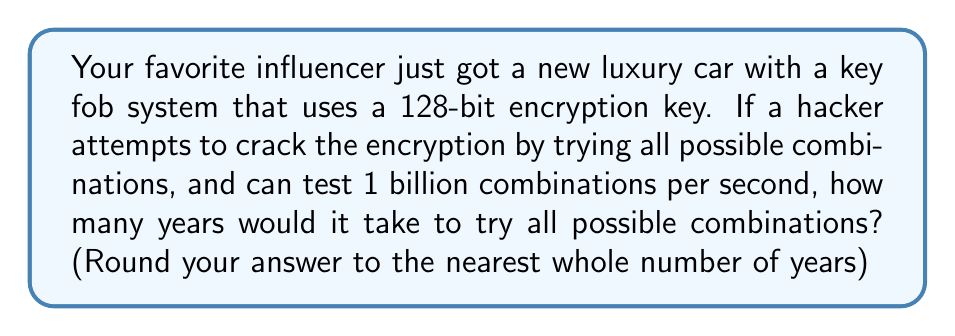Can you solve this math problem? Let's approach this step-by-step:

1) First, we need to calculate the total number of possible combinations for a 128-bit key:
   $$ 2^{128} = 3.4028237 \times 10^{38} \text{ combinations} $$

2) The hacker can test 1 billion combinations per second:
   $$ 1 \text{ billion} = 1 \times 10^9 \text{ combinations/second} $$

3) To find the time in seconds, we divide the total combinations by the rate:
   $$ \text{Time (seconds)} = \frac{3.4028237 \times 10^{38}}{1 \times 10^9} = 3.4028237 \times 10^{29} \text{ seconds} $$

4) To convert this to years, we need to divide by the number of seconds in a year:
   $$ \text{Seconds in a year} = 365 \times 24 \times 60 \times 60 = 31,536,000 $$

5) Now we can calculate the number of years:
   $$ \text{Years} = \frac{3.4028237 \times 10^{29}}{31,536,000} = 1.0790283 \times 10^{22} \text{ years} $$

6) Rounding to the nearest whole number:
   $$ 1.0790283 \times 10^{22} \approx 1 \times 10^{22} \text{ years} $$
Answer: $1 \times 10^{22}$ years 